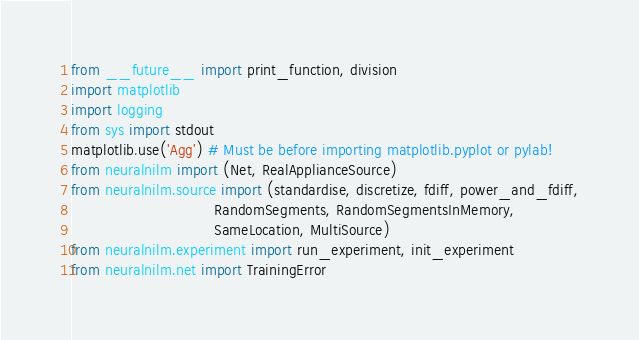Convert code to text. <code><loc_0><loc_0><loc_500><loc_500><_Python_>from __future__ import print_function, division
import matplotlib
import logging
from sys import stdout
matplotlib.use('Agg') # Must be before importing matplotlib.pyplot or pylab!
from neuralnilm import (Net, RealApplianceSource)
from neuralnilm.source import (standardise, discretize, fdiff, power_and_fdiff,
                               RandomSegments, RandomSegmentsInMemory,
                               SameLocation, MultiSource)
from neuralnilm.experiment import run_experiment, init_experiment
from neuralnilm.net import TrainingError</code> 